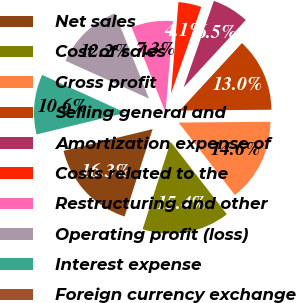Convert chart to OTSL. <chart><loc_0><loc_0><loc_500><loc_500><pie_chart><fcel>Net sales<fcel>Cost of sales<fcel>Gross profit<fcel>Selling general and<fcel>Amortization expense of<fcel>Costs related to the<fcel>Restructuring and other<fcel>Operating profit (loss)<fcel>Interest expense<fcel>Foreign currency exchange<nl><fcel>16.26%<fcel>15.45%<fcel>14.63%<fcel>13.01%<fcel>6.5%<fcel>4.07%<fcel>7.32%<fcel>12.2%<fcel>10.57%<fcel>0.0%<nl></chart> 